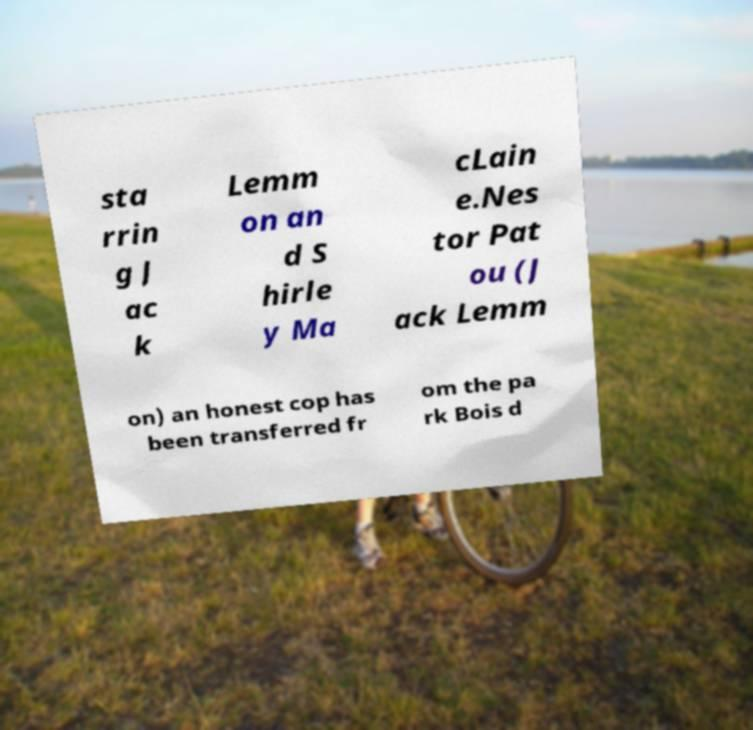For documentation purposes, I need the text within this image transcribed. Could you provide that? sta rrin g J ac k Lemm on an d S hirle y Ma cLain e.Nes tor Pat ou (J ack Lemm on) an honest cop has been transferred fr om the pa rk Bois d 